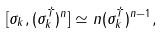Convert formula to latex. <formula><loc_0><loc_0><loc_500><loc_500>[ \sigma _ { k } , ( \sigma _ { k } ^ { \dagger } ) ^ { n } ] \simeq n ( \sigma _ { k } ^ { \dagger } ) ^ { n - 1 } ,</formula> 